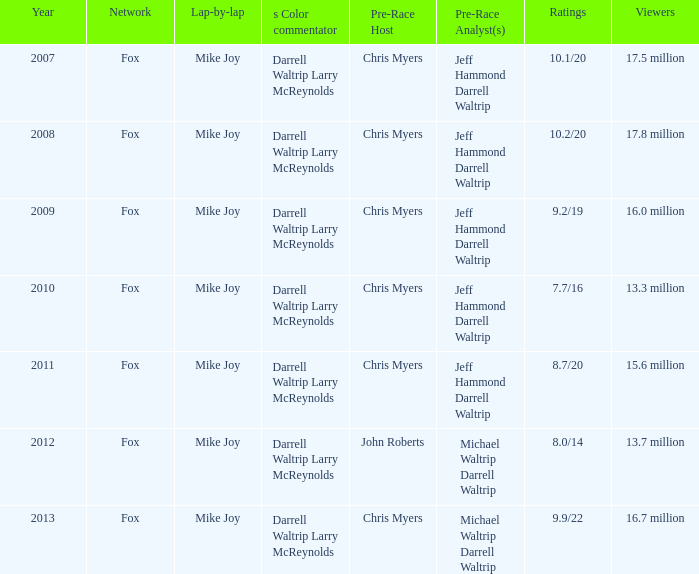9/22 as its ratings? Mike Joy. 